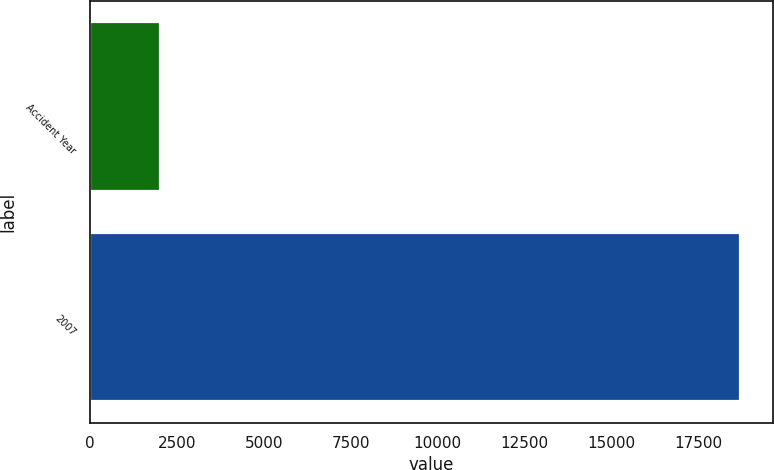Convert chart. <chart><loc_0><loc_0><loc_500><loc_500><bar_chart><fcel>Accident Year<fcel>2007<nl><fcel>2009<fcel>18713<nl></chart> 